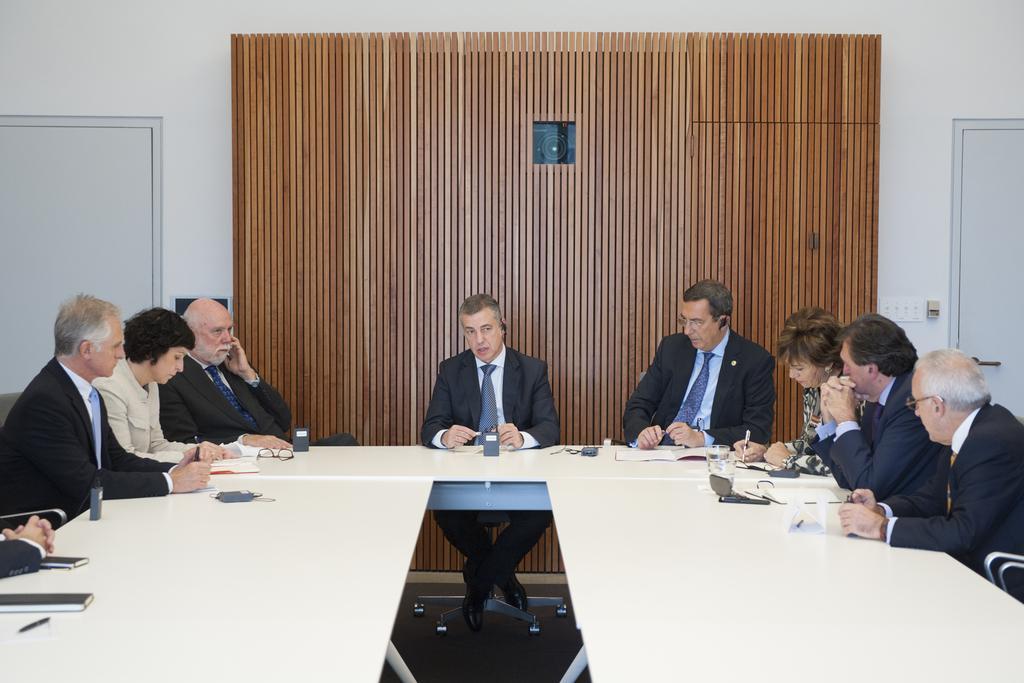Describe this image in one or two sentences. In the image we can see there are lot of people who are sitting on chair and in front of them there is a table. 